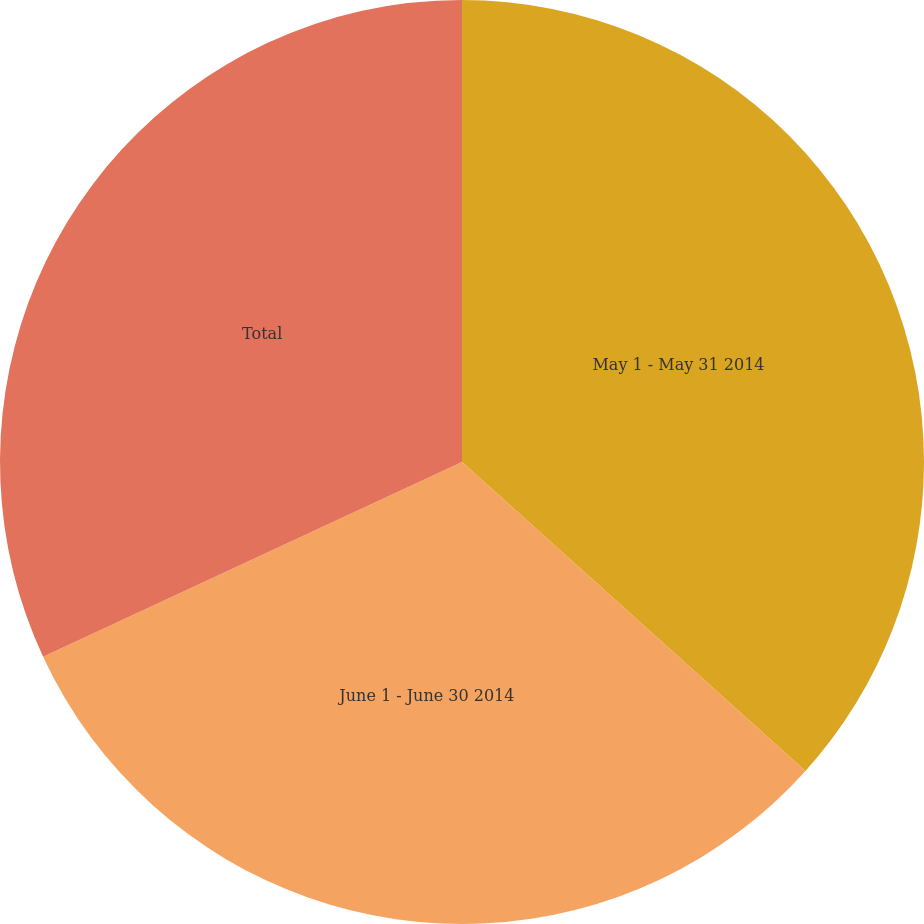Convert chart to OTSL. <chart><loc_0><loc_0><loc_500><loc_500><pie_chart><fcel>May 1 - May 31 2014<fcel>June 1 - June 30 2014<fcel>Total<nl><fcel>36.66%<fcel>31.41%<fcel>31.93%<nl></chart> 